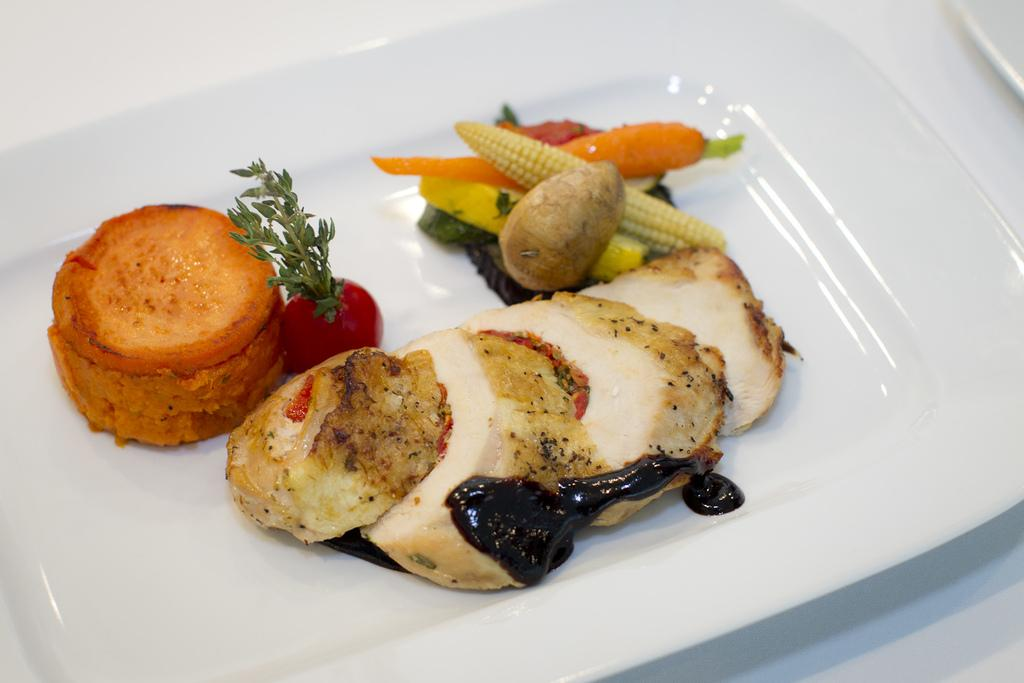What type of food items can be seen in the image? There is a group of vegetables in the image, including carrots, corn, and potatoes. Can you describe the specific vegetables present in the image? Yes, carrots, corn, and potatoes are present in the image. How are the vegetables arranged in the image? The vegetables are placed in a plate in the image. What type of apparel is being used to cook the vegetables in the image? There is no apparel present in the image, and the vegetables are not being cooked. 